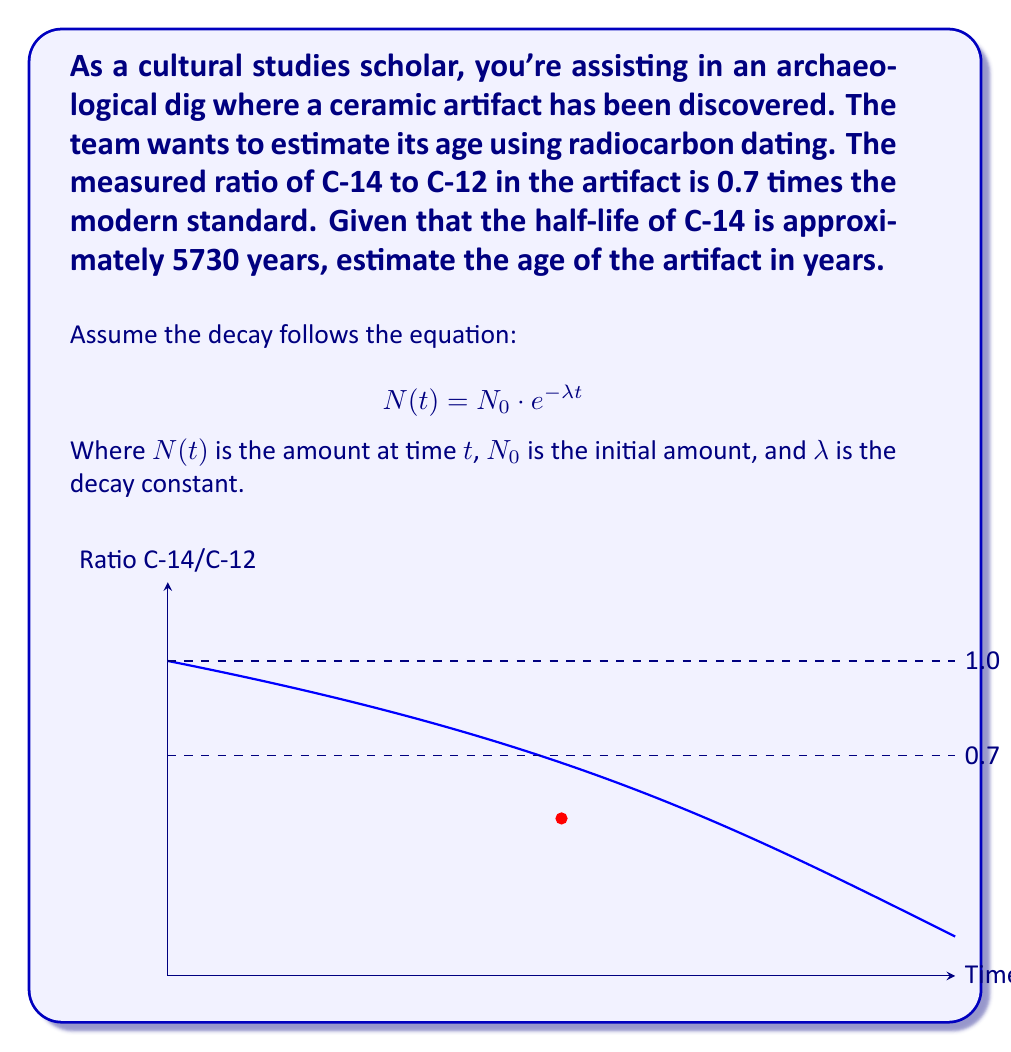Can you answer this question? Let's approach this step-by-step:

1) First, we need to find the decay constant $\lambda$. The half-life $t_{1/2}$ is related to $\lambda$ by:

   $$\lambda = \frac{\ln(2)}{t_{1/2}}$$

2) Substituting the given half-life:

   $$\lambda = \frac{\ln(2)}{5730} \approx 1.21 \times 10^{-4} \text{ year}^{-1}$$

3) Now, we can use the decay equation. Let $N_0$ be the initial amount and $N(t)$ be the amount after time $t$:

   $$\frac{N(t)}{N_0} = e^{-\lambda t}$$

4) We're given that the current ratio is 0.7 times the modern standard, so:

   $$0.7 = e^{-\lambda t}$$

5) Taking the natural logarithm of both sides:

   $$\ln(0.7) = -\lambda t$$

6) Solving for $t$:

   $$t = -\frac{\ln(0.7)}{\lambda}$$

7) Substituting the value of $\lambda$ we calculated:

   $$t = -\frac{\ln(0.7)}{1.21 \times 10^{-4}} \approx 2960 \text{ years}$$

Thus, the estimated age of the artifact is approximately 2960 years.
Answer: 2960 years 